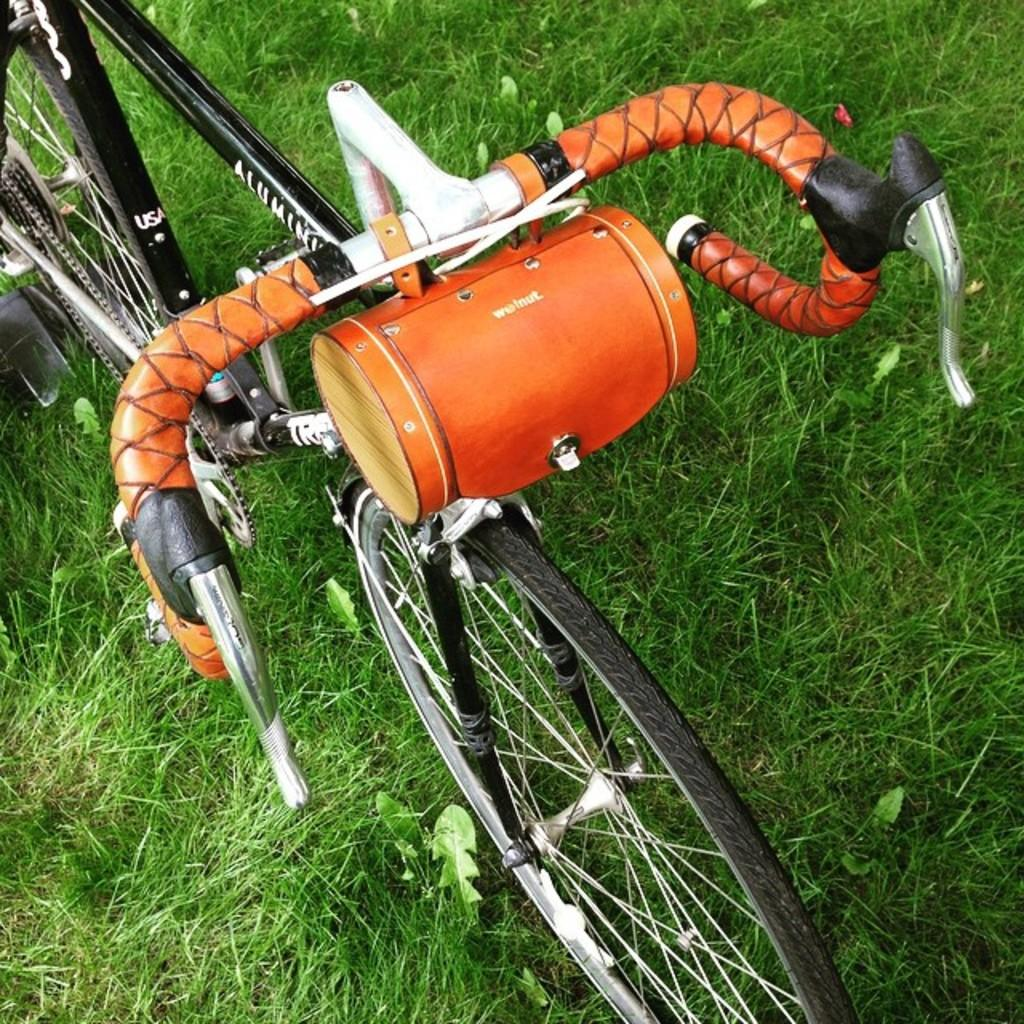What is the main object in the image? There is a cycle in the image. Where is the cycle located? The cycle is on the grass. How does the cycle cry in the image? The cycle does not cry in the image, as it is an inanimate object and cannot experience emotions. 